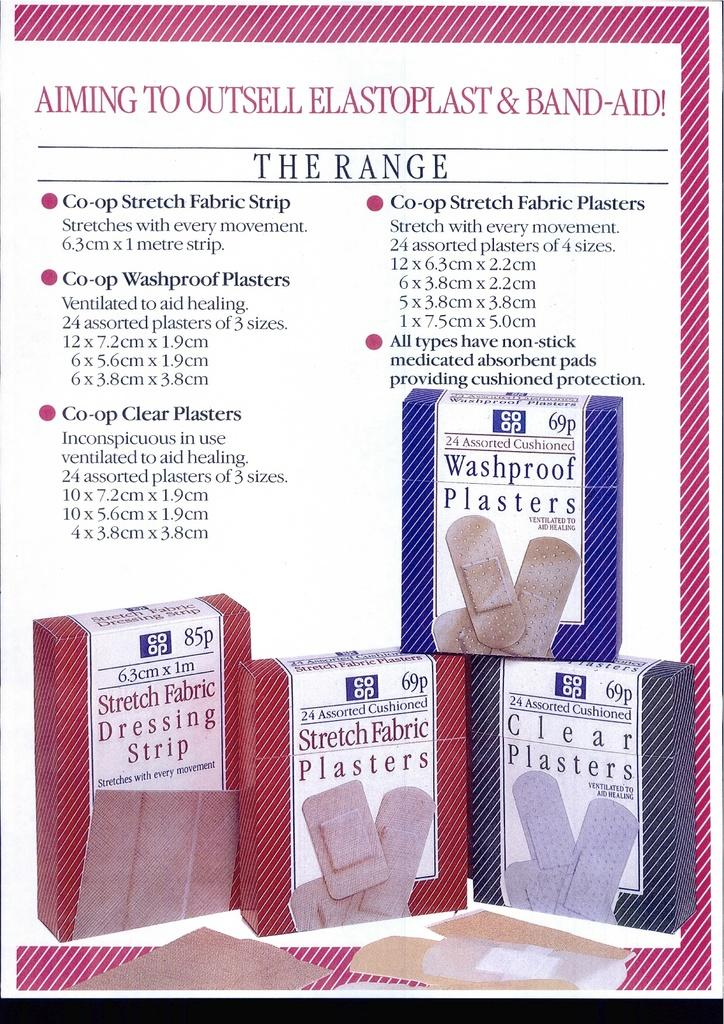What is the main subject of the image? The main subject of the image is a paper. What type of content is on the paper? The paper contains images of bandage boxes. Is there any text on the paper? Yes, there is text written on the paper. How many roses can be seen on the paper in the image? There are no roses present on the paper in the image. What type of expression does the stranger have in the image? There is no stranger present in the image. 